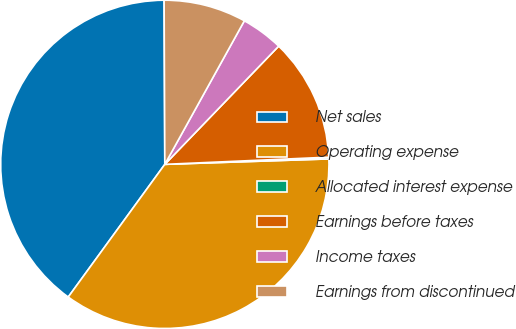Convert chart to OTSL. <chart><loc_0><loc_0><loc_500><loc_500><pie_chart><fcel>Net sales<fcel>Operating expense<fcel>Allocated interest expense<fcel>Earnings before taxes<fcel>Income taxes<fcel>Earnings from discontinued<nl><fcel>39.92%<fcel>35.54%<fcel>0.17%<fcel>12.1%<fcel>4.15%<fcel>8.12%<nl></chart> 